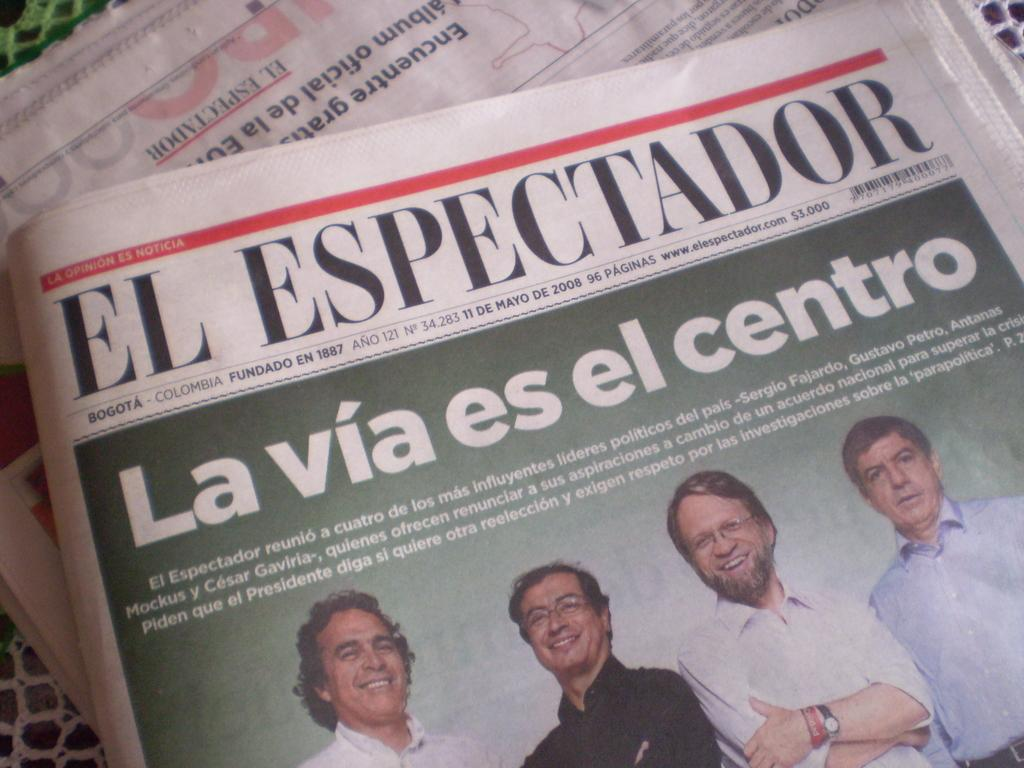What objects are on the platform in the image? There are newspapers on a platform in the image. Can you describe the people visible in the image? There are people visible in the image, but their specific characteristics are not mentioned in the facts. What can be read or seen in terms of text in the image? There is text visible on the platform or newspapers in the image. What type of tent is set up near the platform in the image? There is no tent present in the image; it only features newspapers on a platform and people. What store is located next to the platform in the image? There is no store mentioned or visible in the image; it only features newspapers on a platform and people. 